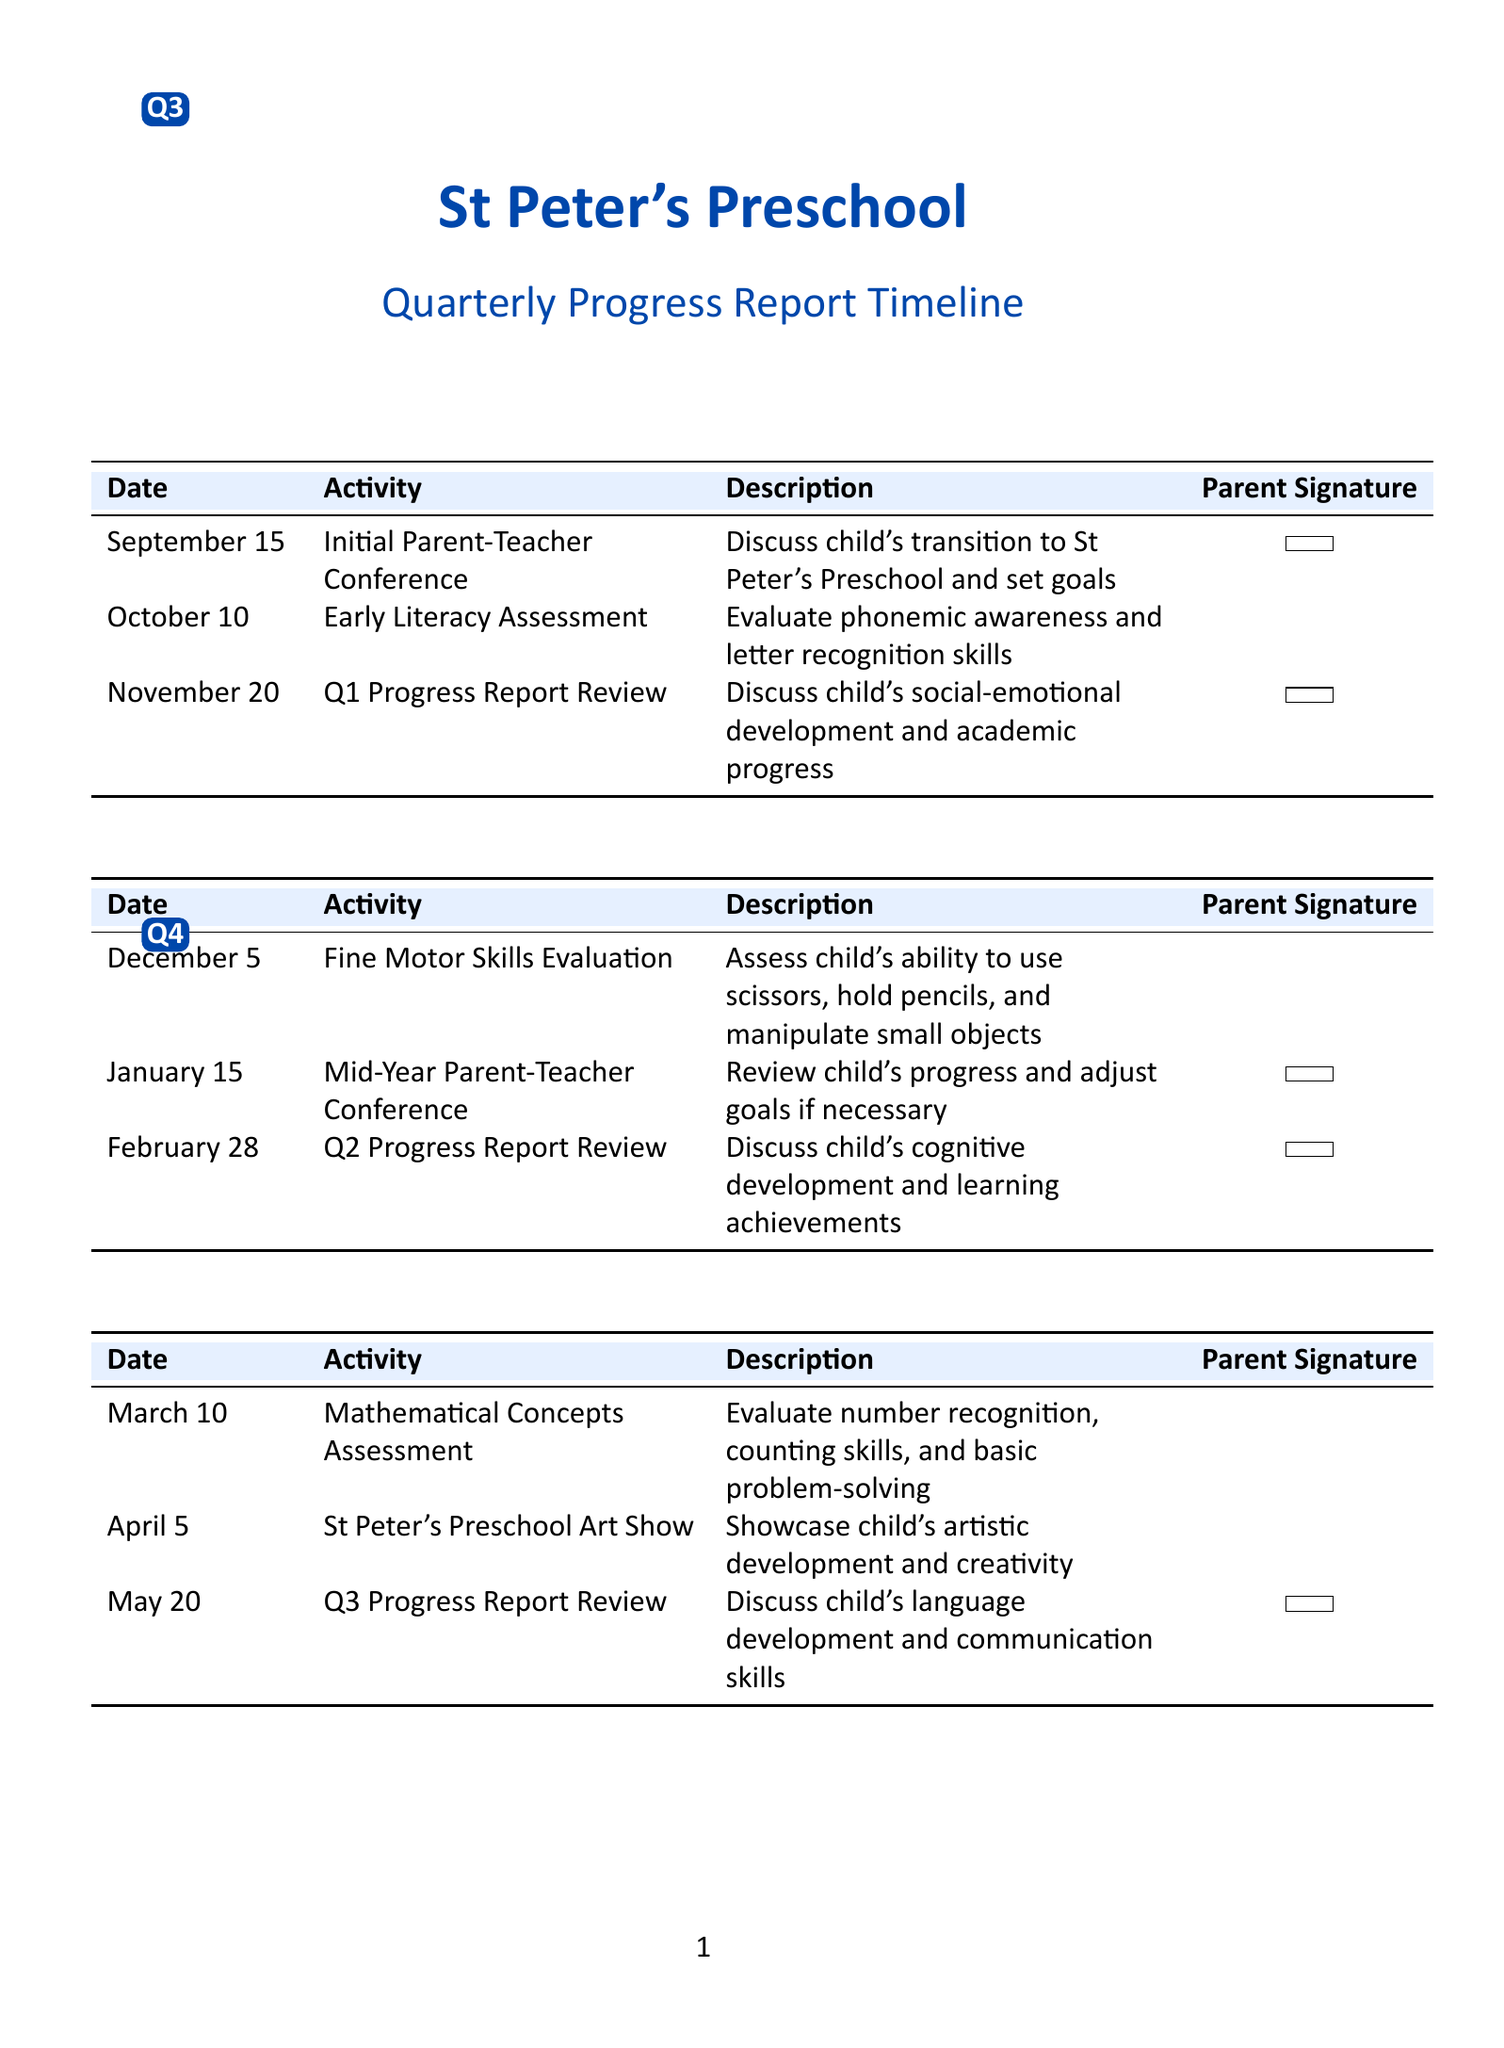What is the date of the Initial Parent-Teacher Conference? The date for the Initial Parent-Teacher Conference is specified in the Q1 milestones.
Answer: September 15 What activity is scheduled for February 28? This activity is outlined in the Q2 milestones, indicating the events for that date.
Answer: Q2 Progress Report Review How many milestones require a parent signature in Q3? A review of the Q3 milestones shows the number of activities that need a parent signature.
Answer: 1 What is the purpose of the Mid-Year Parent-Teacher Conference? The document describes the main objective of this conference in the Q2 milestones.
Answer: Review child's progress and adjust goals if necessary Which quarter includes the St Peter's Preschool Art Show? The document lists the activities under each quarter indicating where this event falls.
Answer: Q3 